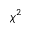<formula> <loc_0><loc_0><loc_500><loc_500>\chi ^ { 2 }</formula> 